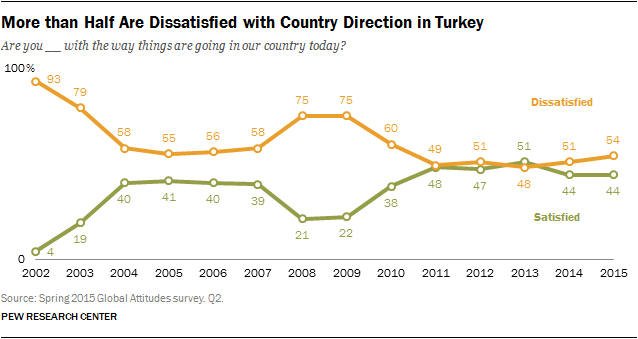List a handful of essential elements in this visual. The difference between the orange and green graphs is maximum in the year 2002. The color of the graph is not orange, and its lowest value is 4. 